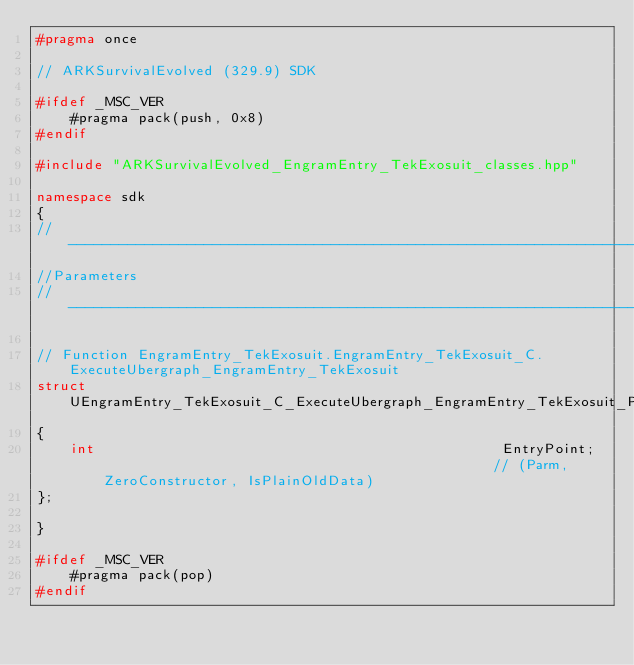<code> <loc_0><loc_0><loc_500><loc_500><_C++_>#pragma once

// ARKSurvivalEvolved (329.9) SDK

#ifdef _MSC_VER
	#pragma pack(push, 0x8)
#endif

#include "ARKSurvivalEvolved_EngramEntry_TekExosuit_classes.hpp"

namespace sdk
{
//---------------------------------------------------------------------------
//Parameters
//---------------------------------------------------------------------------

// Function EngramEntry_TekExosuit.EngramEntry_TekExosuit_C.ExecuteUbergraph_EngramEntry_TekExosuit
struct UEngramEntry_TekExosuit_C_ExecuteUbergraph_EngramEntry_TekExosuit_Params
{
	int                                                EntryPoint;                                               // (Parm, ZeroConstructor, IsPlainOldData)
};

}

#ifdef _MSC_VER
	#pragma pack(pop)
#endif
</code> 